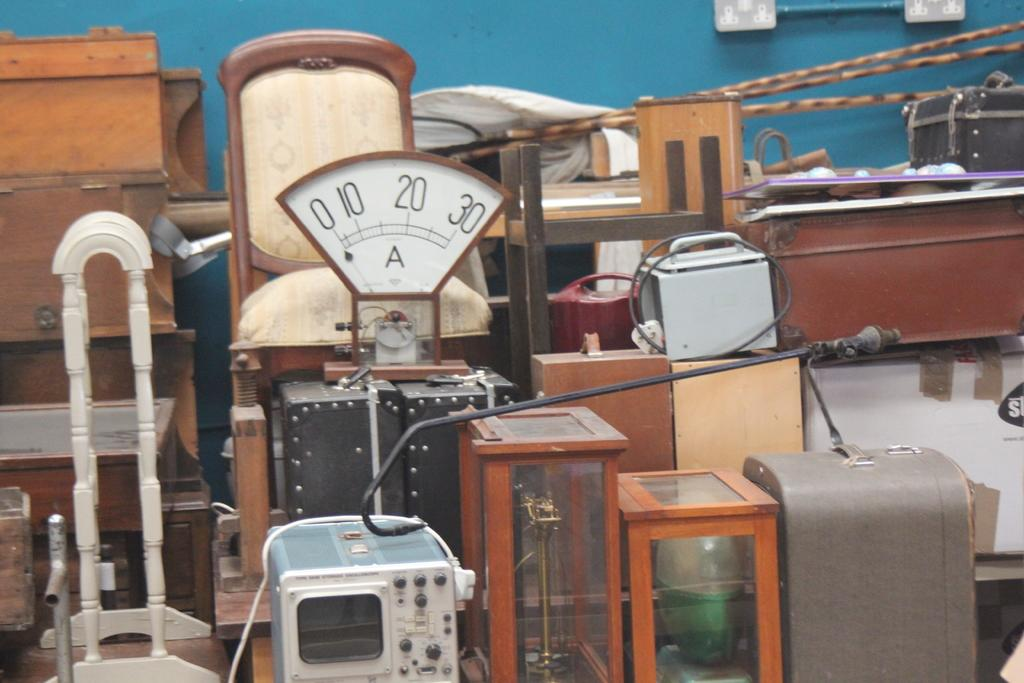What type of material is used for the objects in the image? The objects in the image are made of wood. What color is the background wall in the image? The background wall is blue in color. Are there any bears visible in the image? No, there are no bears present in the image. What type of plants can be seen growing on the wooden objects in the image? There are no plants visible on the wooden objects in the image. 